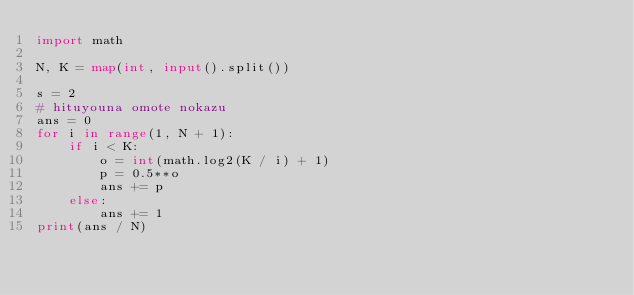Convert code to text. <code><loc_0><loc_0><loc_500><loc_500><_Python_>import math

N, K = map(int, input().split())

s = 2
# hituyouna omote nokazu
ans = 0
for i in range(1, N + 1):
    if i < K:
        o = int(math.log2(K / i) + 1)
        p = 0.5**o
        ans += p
    else:
        ans += 1
print(ans / N)
</code> 